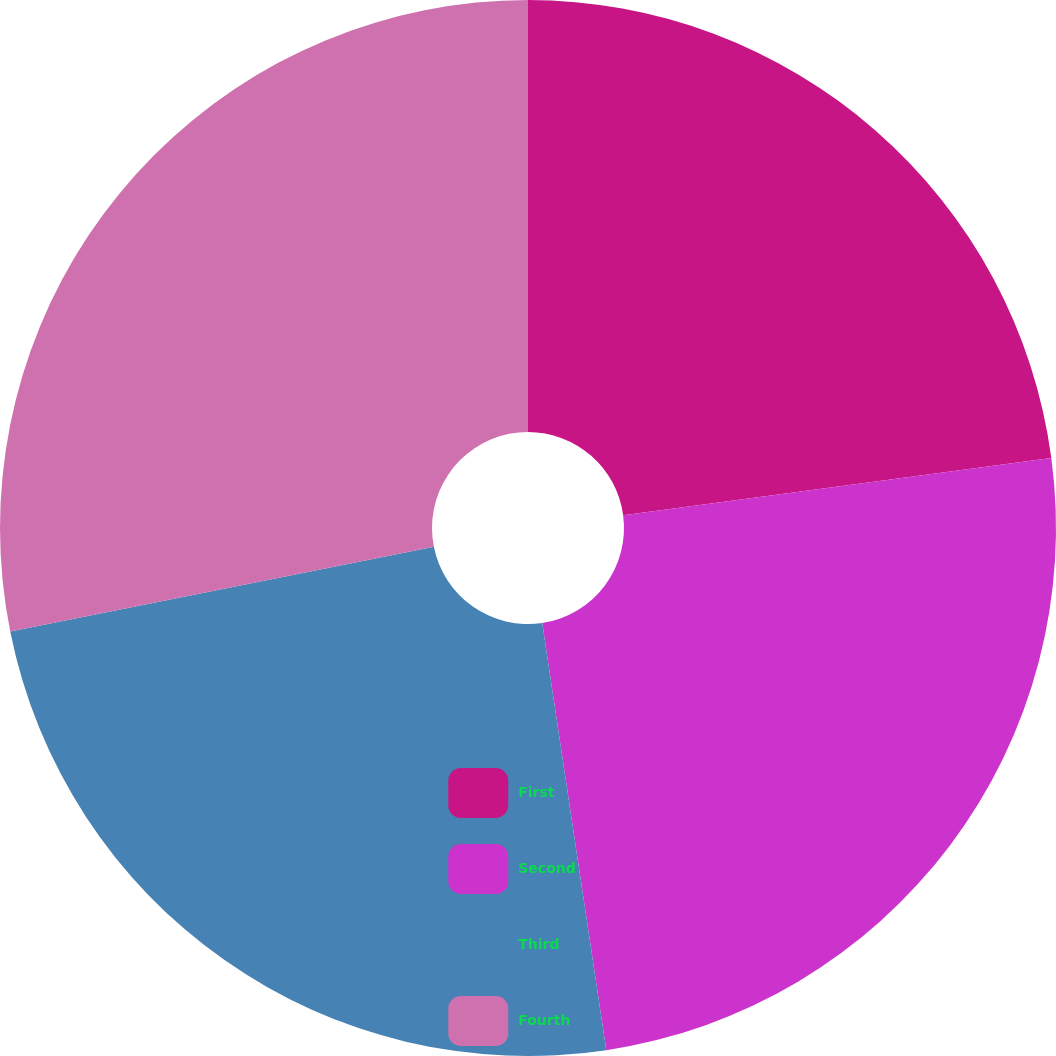Convert chart to OTSL. <chart><loc_0><loc_0><loc_500><loc_500><pie_chart><fcel>First<fcel>Second<fcel>Third<fcel>Fourth<nl><fcel>22.88%<fcel>24.75%<fcel>24.23%<fcel>28.14%<nl></chart> 